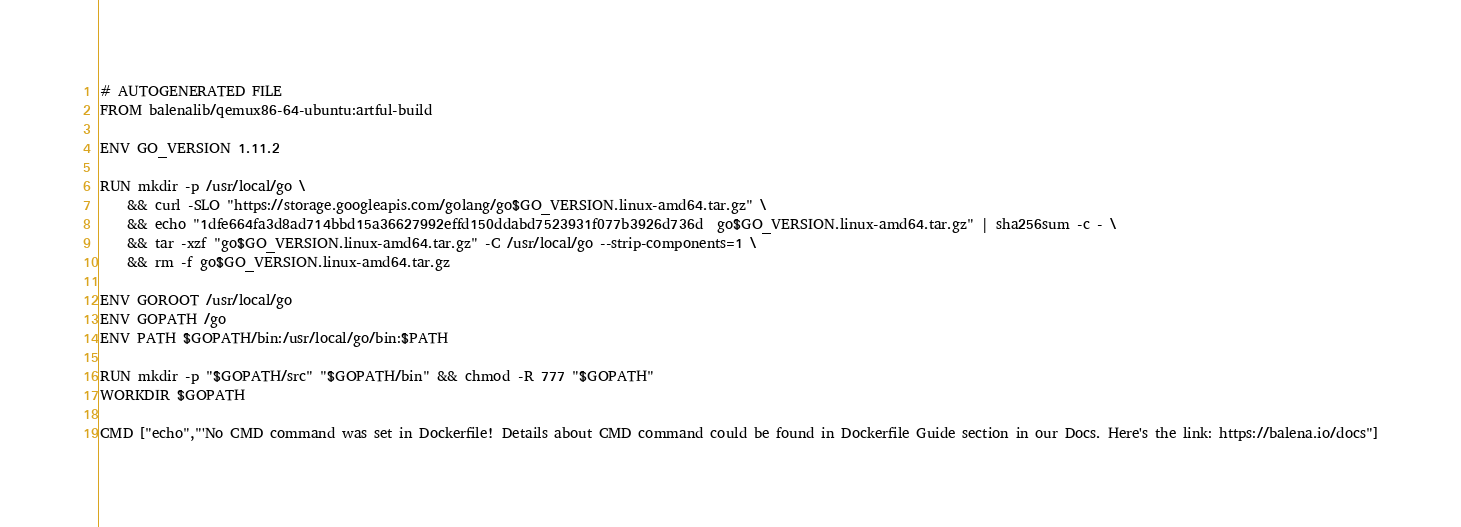Convert code to text. <code><loc_0><loc_0><loc_500><loc_500><_Dockerfile_># AUTOGENERATED FILE
FROM balenalib/qemux86-64-ubuntu:artful-build

ENV GO_VERSION 1.11.2

RUN mkdir -p /usr/local/go \
	&& curl -SLO "https://storage.googleapis.com/golang/go$GO_VERSION.linux-amd64.tar.gz" \
	&& echo "1dfe664fa3d8ad714bbd15a36627992effd150ddabd7523931f077b3926d736d  go$GO_VERSION.linux-amd64.tar.gz" | sha256sum -c - \
	&& tar -xzf "go$GO_VERSION.linux-amd64.tar.gz" -C /usr/local/go --strip-components=1 \
	&& rm -f go$GO_VERSION.linux-amd64.tar.gz

ENV GOROOT /usr/local/go
ENV GOPATH /go
ENV PATH $GOPATH/bin:/usr/local/go/bin:$PATH

RUN mkdir -p "$GOPATH/src" "$GOPATH/bin" && chmod -R 777 "$GOPATH"
WORKDIR $GOPATH

CMD ["echo","'No CMD command was set in Dockerfile! Details about CMD command could be found in Dockerfile Guide section in our Docs. Here's the link: https://balena.io/docs"]</code> 